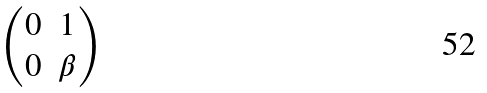<formula> <loc_0><loc_0><loc_500><loc_500>\begin{pmatrix} 0 & 1 \\ 0 & \beta \end{pmatrix}</formula> 